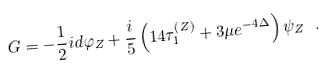Convert formula to latex. <formula><loc_0><loc_0><loc_500><loc_500>G = - \frac { 1 } { 2 } i d \varphi _ { Z } + \frac { i } { 5 } \left ( 1 4 \tau _ { 1 } ^ { \left ( Z \right ) } + 3 \mu e ^ { - 4 \Delta } \right ) \psi _ { Z } \ .</formula> 